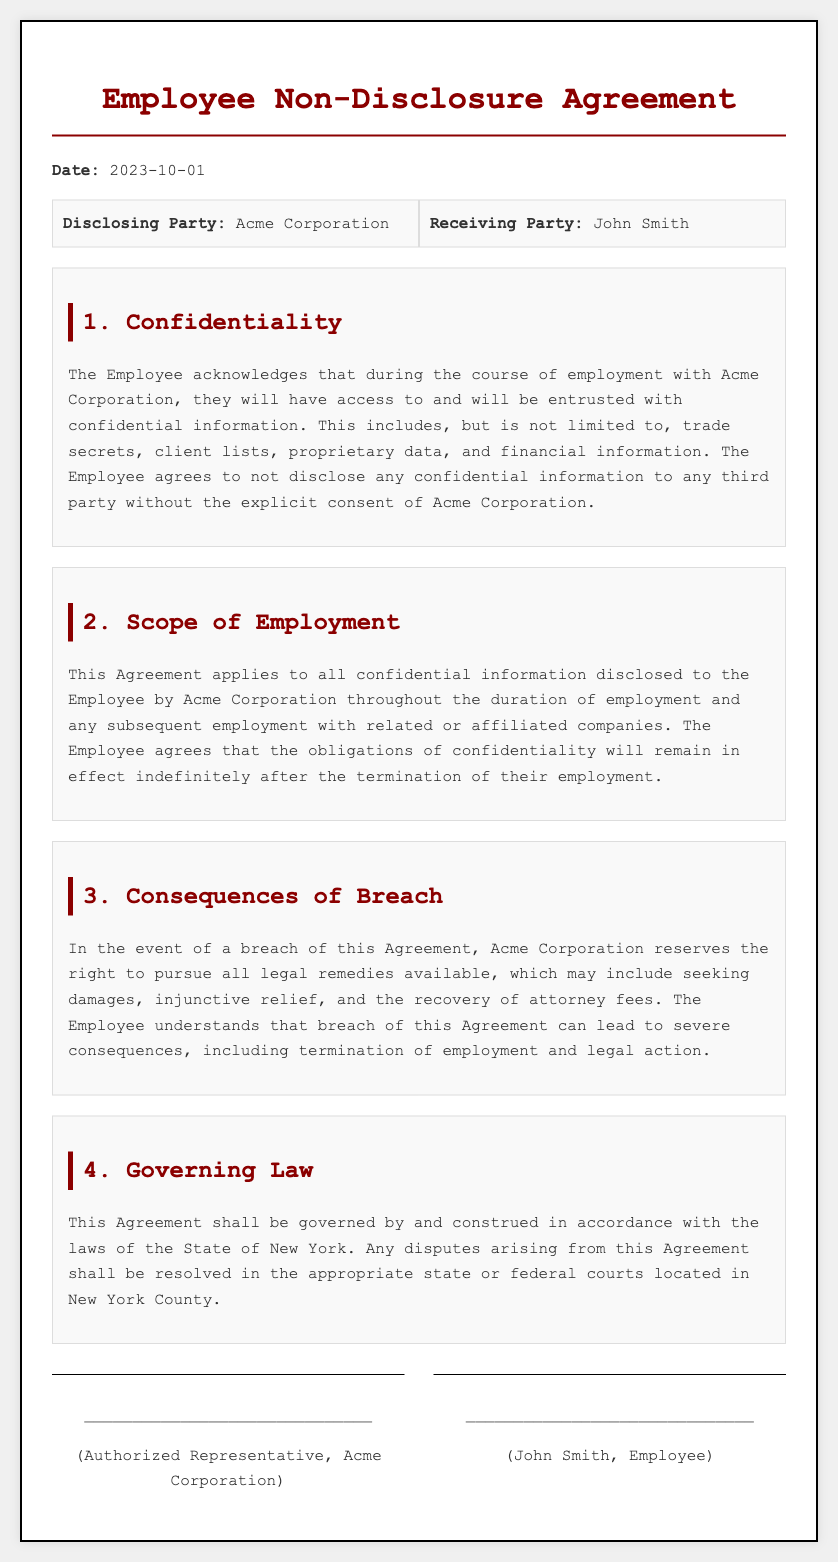What is the date of the agreement? The date is specified in the document under 'Date:', which indicates when the agreement was signed.
Answer: 2023-10-01 Who is the Disclosing Party? The Disclosing Party is stated clearly in the section where both parties are identified.
Answer: Acme Corporation What is included in confidential information? The document lists examples of what is considered confidential information, which includes specific categories.
Answer: trade secrets, client lists, proprietary data, financial information What happens if the Employee breaches the agreement? The consequences of a breach are outlined, specifying the rights of the Disclosing Party.
Answer: legal remedies Where will disputes be resolved? The document states where legal disputes will be resolved in relation to the agreement.
Answer: New York County What is the duration of the confidentiality obligations? The agreement specifies how long the confidentiality obligations last post-employment.
Answer: indefinitely What must the Employee do before disclosing confidential information? The requirement for disclosure before an employee can share confidential information is detailed in the document.
Answer: explicit consent What type of legal action can Acme Corporation pursue? The types of legal actions that can be taken in case of a breach are listed within the consequences section.
Answer: damages, injunctive relief, recovery of attorney fees 